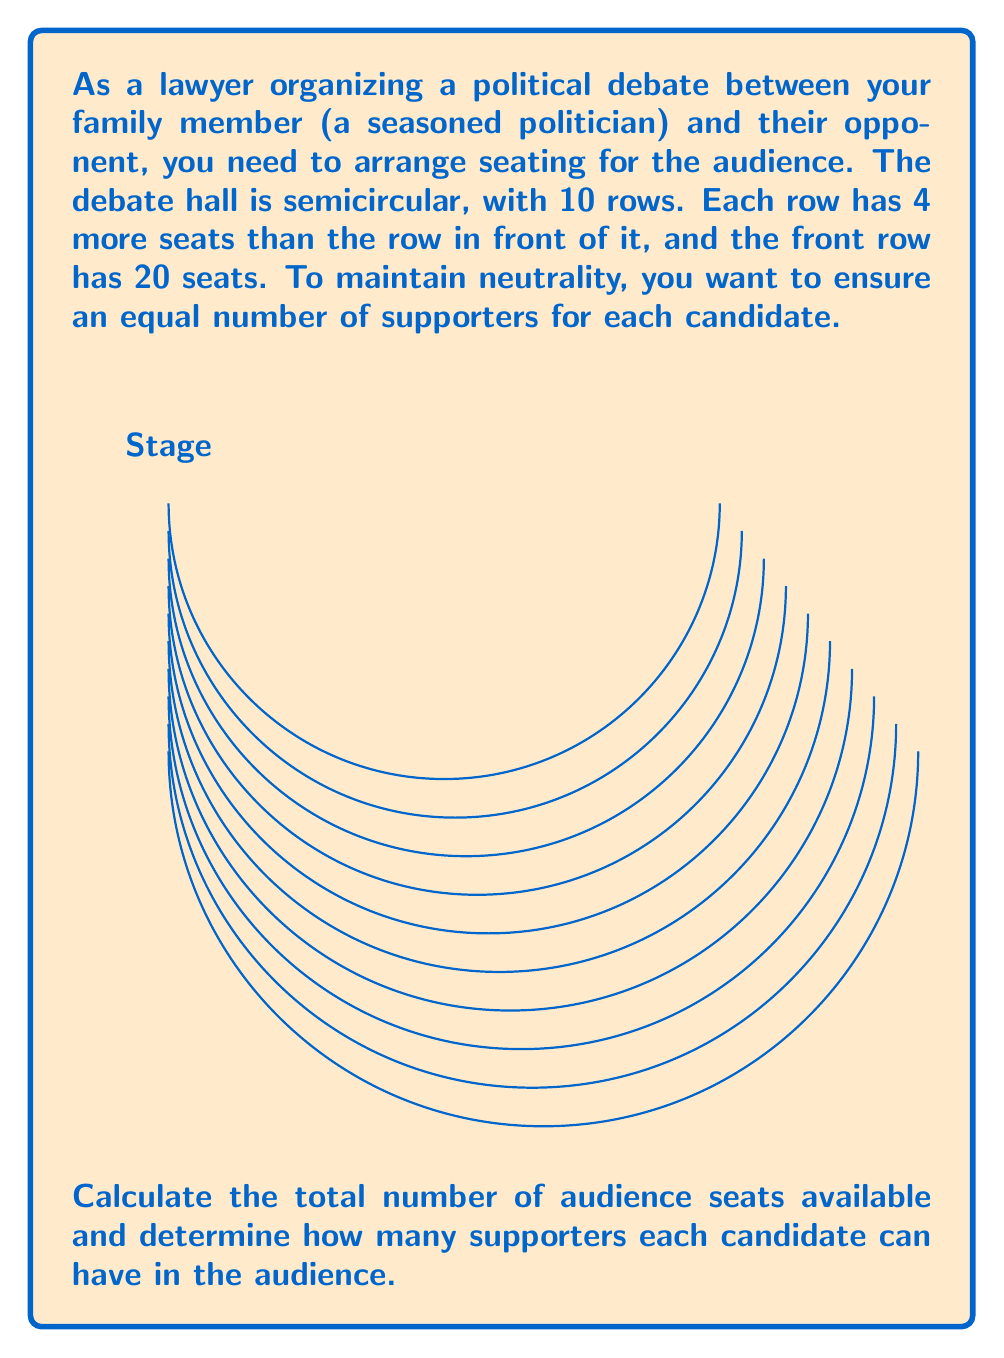Can you answer this question? Let's approach this step-by-step:

1) First, we need to find the number of seats in each row. We know that:
   - The front row has 20 seats
   - Each subsequent row has 4 more seats than the one in front of it

2) We can represent this as an arithmetic sequence:
   $a_1 = 20$ (first term)
   $d = 4$ (common difference)
   $n = 10$ (number of terms/rows)

3) The number of seats in each row can be represented as:
   Row 1: $20$
   Row 2: $20 + 4 = 24$
   Row 3: $24 + 4 = 28$
   ...
   Row 10: $20 + 9(4) = 56$

4) To find the total number of seats, we need to sum this arithmetic sequence. We can use the formula for the sum of an arithmetic sequence:

   $S_n = \frac{n}{2}(a_1 + a_n)$

   Where $a_n = a_1 + (n-1)d = 20 + (10-1)4 = 56$

5) Plugging in our values:

   $S_{10} = \frac{10}{2}(20 + 56) = 5(76) = 380$

6) Therefore, the total number of seats is 380.

7) To ensure neutrality, we want an equal number of supporters for each candidate. We simply divide the total by 2:

   $380 \div 2 = 190$

Thus, each candidate can have 190 supporters in the audience.
Answer: 190 supporters per candidate 